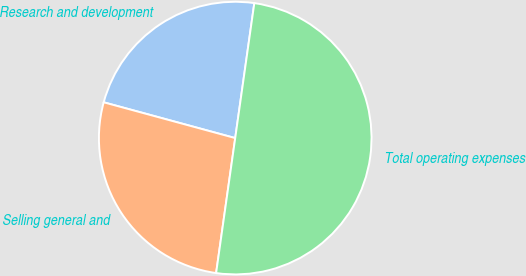Convert chart. <chart><loc_0><loc_0><loc_500><loc_500><pie_chart><fcel>Research and development<fcel>Selling general and<fcel>Total operating expenses<nl><fcel>23.01%<fcel>26.99%<fcel>50.0%<nl></chart> 